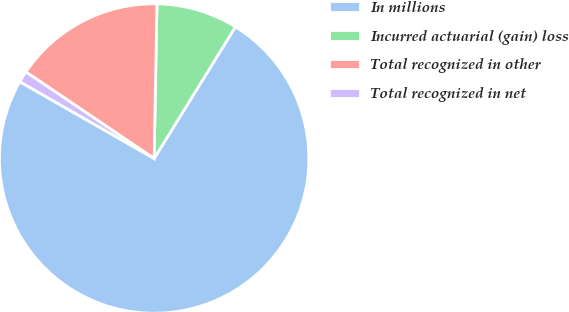Convert chart. <chart><loc_0><loc_0><loc_500><loc_500><pie_chart><fcel>In millions<fcel>Incurred actuarial (gain) loss<fcel>Total recognized in other<fcel>Total recognized in net<nl><fcel>74.46%<fcel>8.51%<fcel>15.84%<fcel>1.18%<nl></chart> 